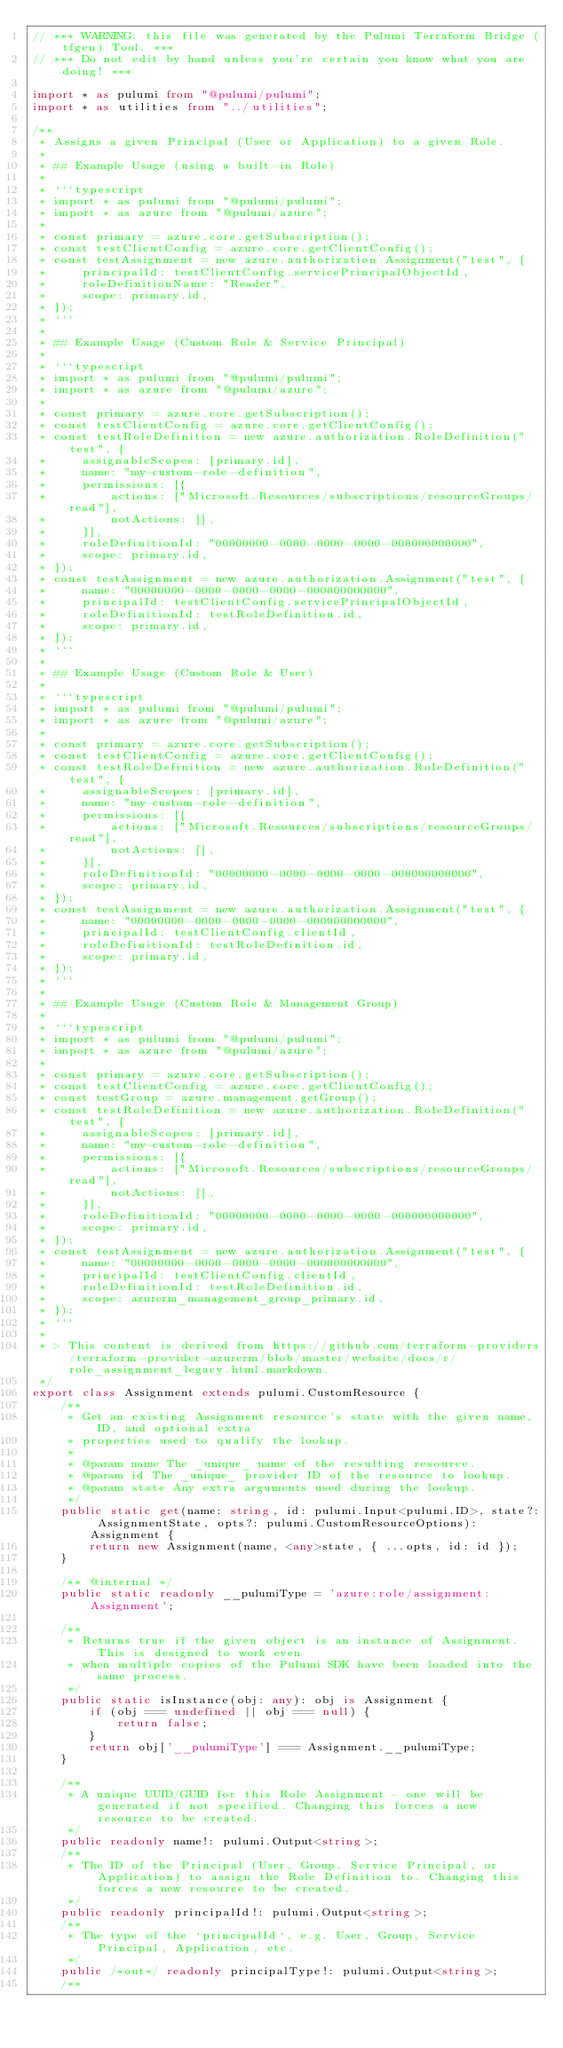Convert code to text. <code><loc_0><loc_0><loc_500><loc_500><_TypeScript_>// *** WARNING: this file was generated by the Pulumi Terraform Bridge (tfgen) Tool. ***
// *** Do not edit by hand unless you're certain you know what you are doing! ***

import * as pulumi from "@pulumi/pulumi";
import * as utilities from "../utilities";

/**
 * Assigns a given Principal (User or Application) to a given Role.
 * 
 * ## Example Usage (using a built-in Role)
 * 
 * ```typescript
 * import * as pulumi from "@pulumi/pulumi";
 * import * as azure from "@pulumi/azure";
 * 
 * const primary = azure.core.getSubscription();
 * const testClientConfig = azure.core.getClientConfig();
 * const testAssignment = new azure.authorization.Assignment("test", {
 *     principalId: testClientConfig.servicePrincipalObjectId,
 *     roleDefinitionName: "Reader",
 *     scope: primary.id,
 * });
 * ```
 * 
 * ## Example Usage (Custom Role & Service Principal)
 * 
 * ```typescript
 * import * as pulumi from "@pulumi/pulumi";
 * import * as azure from "@pulumi/azure";
 * 
 * const primary = azure.core.getSubscription();
 * const testClientConfig = azure.core.getClientConfig();
 * const testRoleDefinition = new azure.authorization.RoleDefinition("test", {
 *     assignableScopes: [primary.id],
 *     name: "my-custom-role-definition",
 *     permissions: [{
 *         actions: ["Microsoft.Resources/subscriptions/resourceGroups/read"],
 *         notActions: [],
 *     }],
 *     roleDefinitionId: "00000000-0000-0000-0000-000000000000",
 *     scope: primary.id,
 * });
 * const testAssignment = new azure.authorization.Assignment("test", {
 *     name: "00000000-0000-0000-0000-000000000000",
 *     principalId: testClientConfig.servicePrincipalObjectId,
 *     roleDefinitionId: testRoleDefinition.id,
 *     scope: primary.id,
 * });
 * ```
 * 
 * ## Example Usage (Custom Role & User)
 * 
 * ```typescript
 * import * as pulumi from "@pulumi/pulumi";
 * import * as azure from "@pulumi/azure";
 * 
 * const primary = azure.core.getSubscription();
 * const testClientConfig = azure.core.getClientConfig();
 * const testRoleDefinition = new azure.authorization.RoleDefinition("test", {
 *     assignableScopes: [primary.id],
 *     name: "my-custom-role-definition",
 *     permissions: [{
 *         actions: ["Microsoft.Resources/subscriptions/resourceGroups/read"],
 *         notActions: [],
 *     }],
 *     roleDefinitionId: "00000000-0000-0000-0000-000000000000",
 *     scope: primary.id,
 * });
 * const testAssignment = new azure.authorization.Assignment("test", {
 *     name: "00000000-0000-0000-0000-000000000000",
 *     principalId: testClientConfig.clientId,
 *     roleDefinitionId: testRoleDefinition.id,
 *     scope: primary.id,
 * });
 * ```
 * 
 * ## Example Usage (Custom Role & Management Group)
 * 
 * ```typescript
 * import * as pulumi from "@pulumi/pulumi";
 * import * as azure from "@pulumi/azure";
 * 
 * const primary = azure.core.getSubscription();
 * const testClientConfig = azure.core.getClientConfig();
 * const testGroup = azure.management.getGroup();
 * const testRoleDefinition = new azure.authorization.RoleDefinition("test", {
 *     assignableScopes: [primary.id],
 *     name: "my-custom-role-definition",
 *     permissions: [{
 *         actions: ["Microsoft.Resources/subscriptions/resourceGroups/read"],
 *         notActions: [],
 *     }],
 *     roleDefinitionId: "00000000-0000-0000-0000-000000000000",
 *     scope: primary.id,
 * });
 * const testAssignment = new azure.authorization.Assignment("test", {
 *     name: "00000000-0000-0000-0000-000000000000",
 *     principalId: testClientConfig.clientId,
 *     roleDefinitionId: testRoleDefinition.id,
 *     scope: azurerm_management_group_primary.id,
 * });
 * ```
 *
 * > This content is derived from https://github.com/terraform-providers/terraform-provider-azurerm/blob/master/website/docs/r/role_assignment_legacy.html.markdown.
 */
export class Assignment extends pulumi.CustomResource {
    /**
     * Get an existing Assignment resource's state with the given name, ID, and optional extra
     * properties used to qualify the lookup.
     *
     * @param name The _unique_ name of the resulting resource.
     * @param id The _unique_ provider ID of the resource to lookup.
     * @param state Any extra arguments used during the lookup.
     */
    public static get(name: string, id: pulumi.Input<pulumi.ID>, state?: AssignmentState, opts?: pulumi.CustomResourceOptions): Assignment {
        return new Assignment(name, <any>state, { ...opts, id: id });
    }

    /** @internal */
    public static readonly __pulumiType = 'azure:role/assignment:Assignment';

    /**
     * Returns true if the given object is an instance of Assignment.  This is designed to work even
     * when multiple copies of the Pulumi SDK have been loaded into the same process.
     */
    public static isInstance(obj: any): obj is Assignment {
        if (obj === undefined || obj === null) {
            return false;
        }
        return obj['__pulumiType'] === Assignment.__pulumiType;
    }

    /**
     * A unique UUID/GUID for this Role Assignment - one will be generated if not specified. Changing this forces a new resource to be created.
     */
    public readonly name!: pulumi.Output<string>;
    /**
     * The ID of the Principal (User, Group, Service Principal, or Application) to assign the Role Definition to. Changing this forces a new resource to be created. 
     */
    public readonly principalId!: pulumi.Output<string>;
    /**
     * The type of the `principalId`, e.g. User, Group, Service Principal, Application, etc.
     */
    public /*out*/ readonly principalType!: pulumi.Output<string>;
    /**</code> 